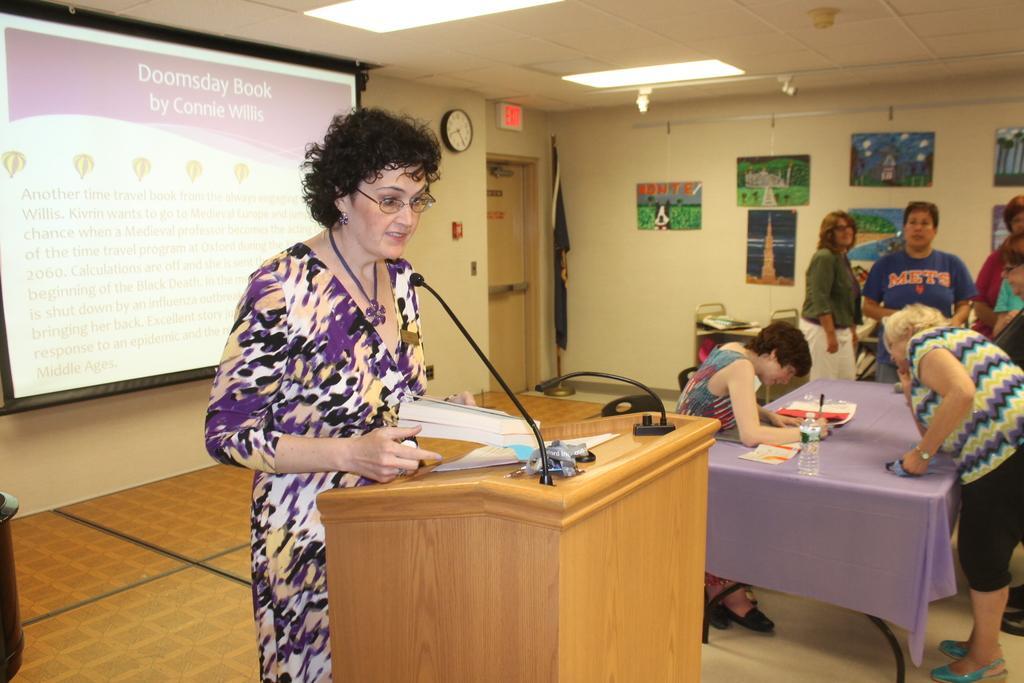In one or two sentences, can you explain what this image depicts? As we can see in the image there is a wall, door, clock, photo frames, screen, few people here and there and there is a table. On table there is a bottle and papers. 